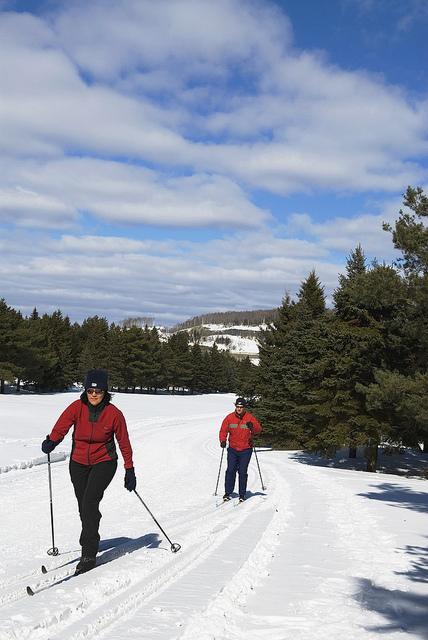Is that skis he's holding?
Concise answer only. No. What color is her hoodie?
Be succinct. Red. Why are there tracks in the snow?
Keep it brief. Skiing. What color is her coat?
Concise answer only. Red. How high are they?
Concise answer only. 8,000 feet. Are they riding fast?
Concise answer only. No. Are they downhill skiing or cross-country skiing?
Be succinct. Cross-country. Are the skiers riding downhill?
Concise answer only. No. How many athletes?
Quick response, please. 2. Are these skiers wearing matching coats?
Write a very short answer. Yes. Are these people skiing?
Quick response, please. Yes. Is there any slope for the skiers?
Write a very short answer. No. Where are bushes?
Give a very brief answer. Right side. Are the skiers facing the camera?
Give a very brief answer. Yes. What is the lady walking up?
Quick response, please. Hill. What color is the sky in this picture?
Keep it brief. Blue. 